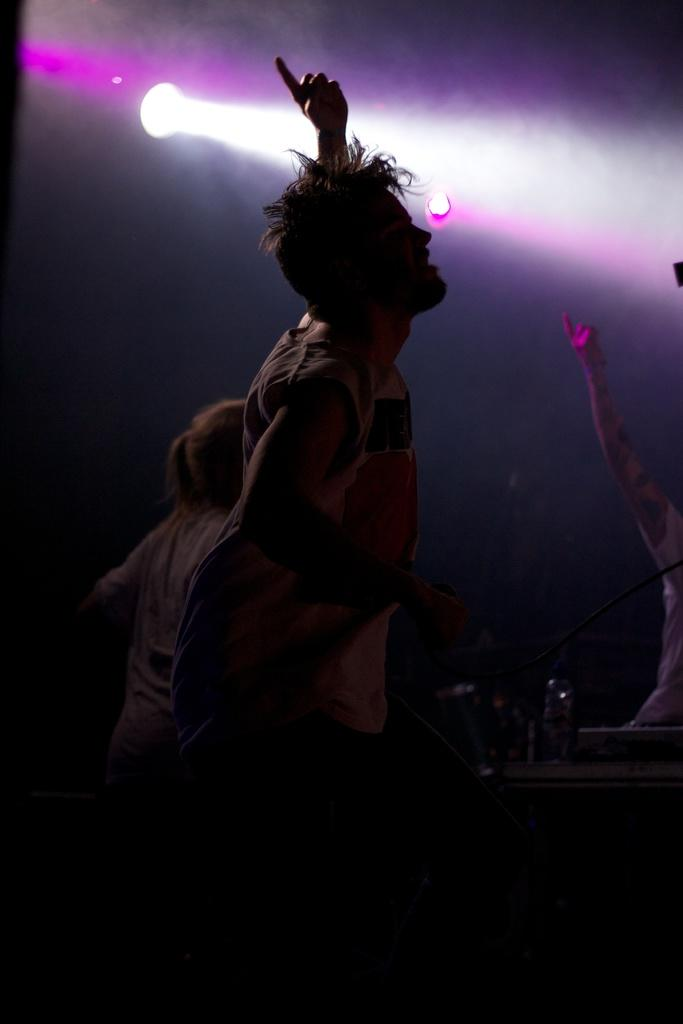What is the main subject of the image? There is a person in the image. What is the person holding in the image? The person is holding a microphone with a wire. What is the person doing in the image? The person is dancing. Can you describe the background of the image? There are objects, people, and lights in the background of the image, and the background view is dark. What type of pie is being served on the hill in the image? There is no pie or hill present in the image. How many pears can be seen on the person in the image? There are no pears visible on the person in the image. 